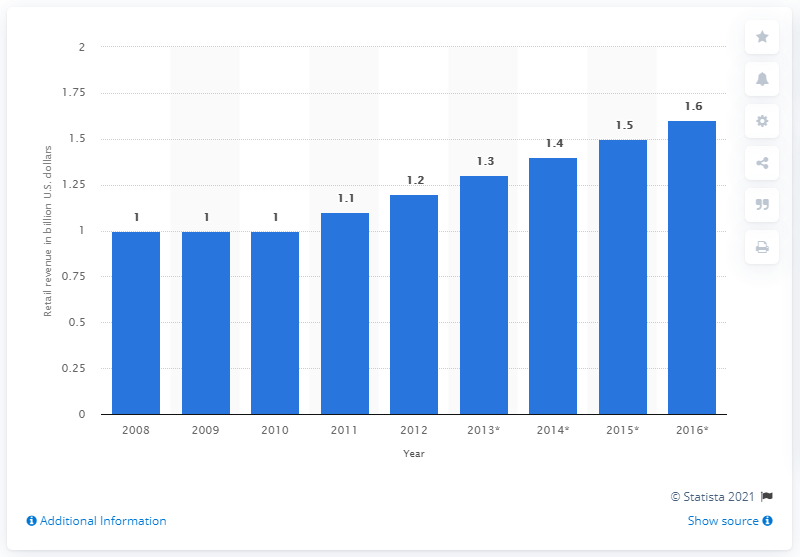Highlight a few significant elements in this photo. According to projections by 2016, the global lingerie market is expected to reach 1.6... 